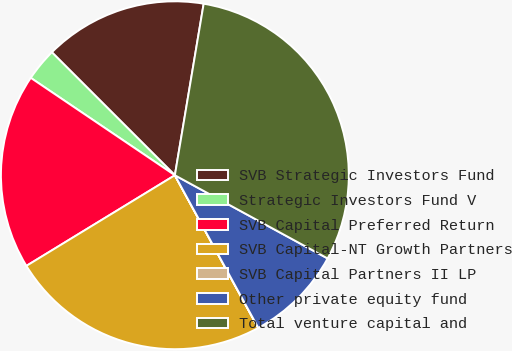Convert chart to OTSL. <chart><loc_0><loc_0><loc_500><loc_500><pie_chart><fcel>SVB Strategic Investors Fund<fcel>Strategic Investors Fund V<fcel>SVB Capital Preferred Return<fcel>SVB Capital-NT Growth Partners<fcel>SVB Capital Partners II LP<fcel>Other private equity fund<fcel>Total venture capital and<nl><fcel>15.15%<fcel>3.04%<fcel>18.18%<fcel>24.23%<fcel>0.01%<fcel>9.1%<fcel>30.29%<nl></chart> 